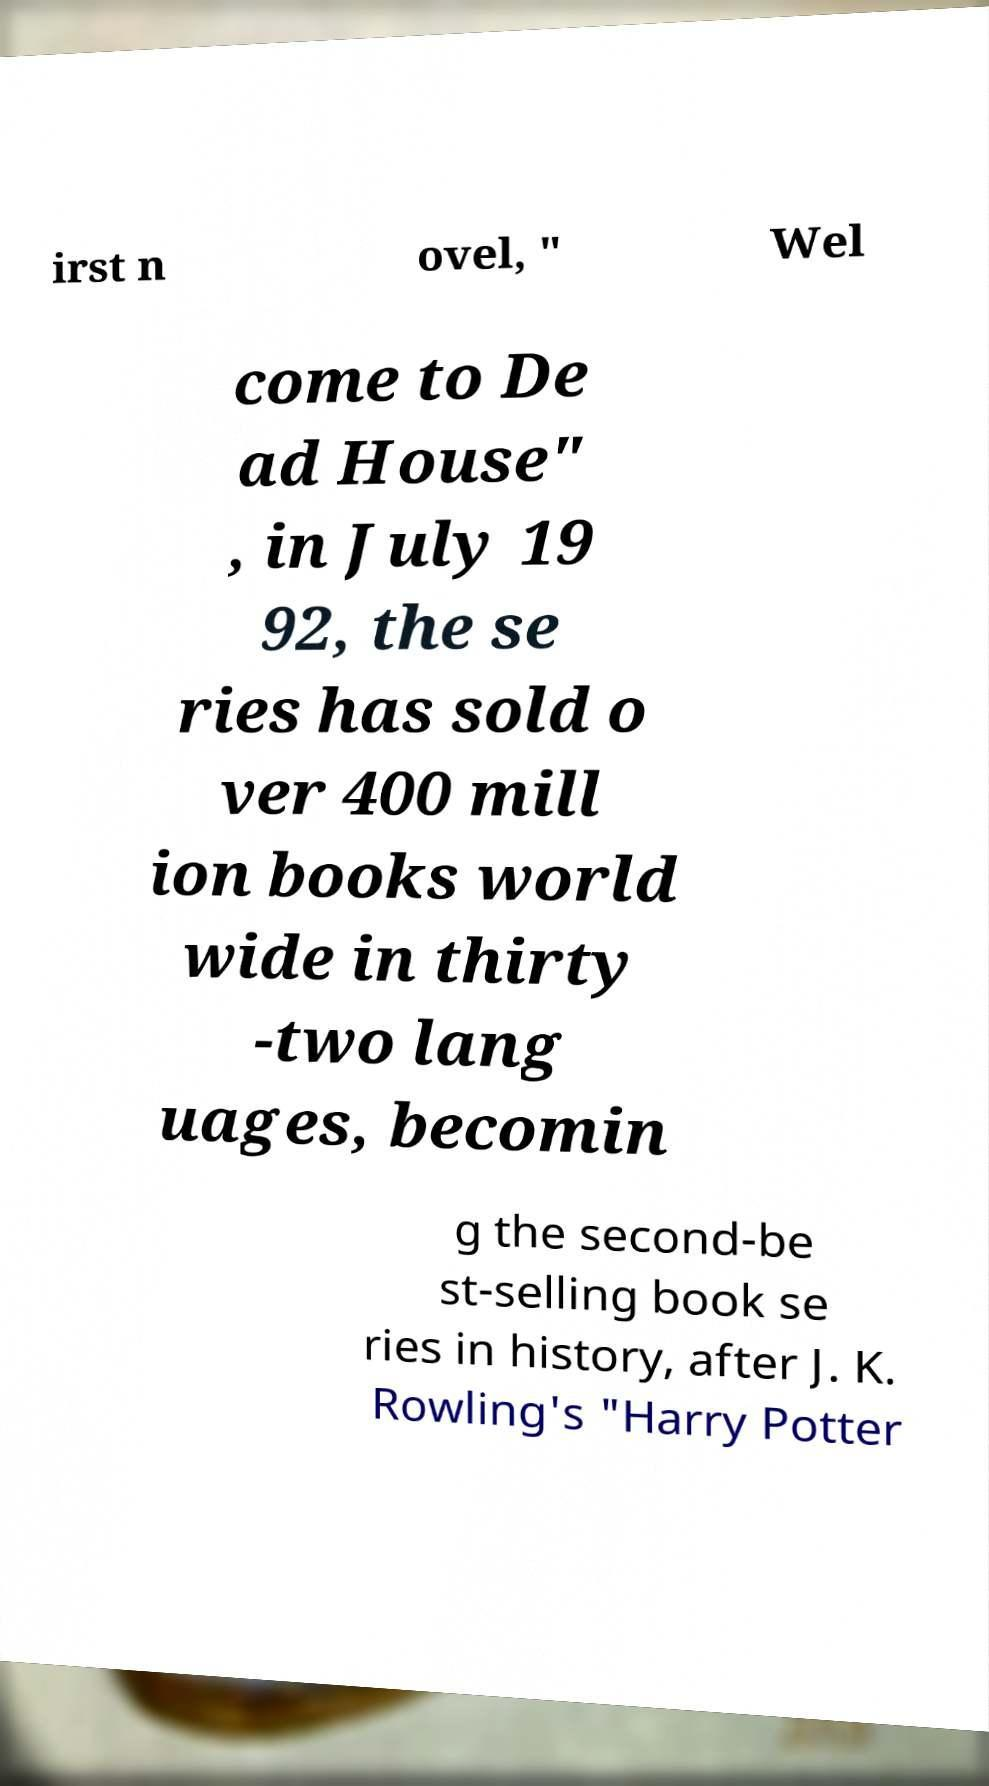Can you accurately transcribe the text from the provided image for me? irst n ovel, " Wel come to De ad House" , in July 19 92, the se ries has sold o ver 400 mill ion books world wide in thirty -two lang uages, becomin g the second-be st-selling book se ries in history, after J. K. Rowling's "Harry Potter 